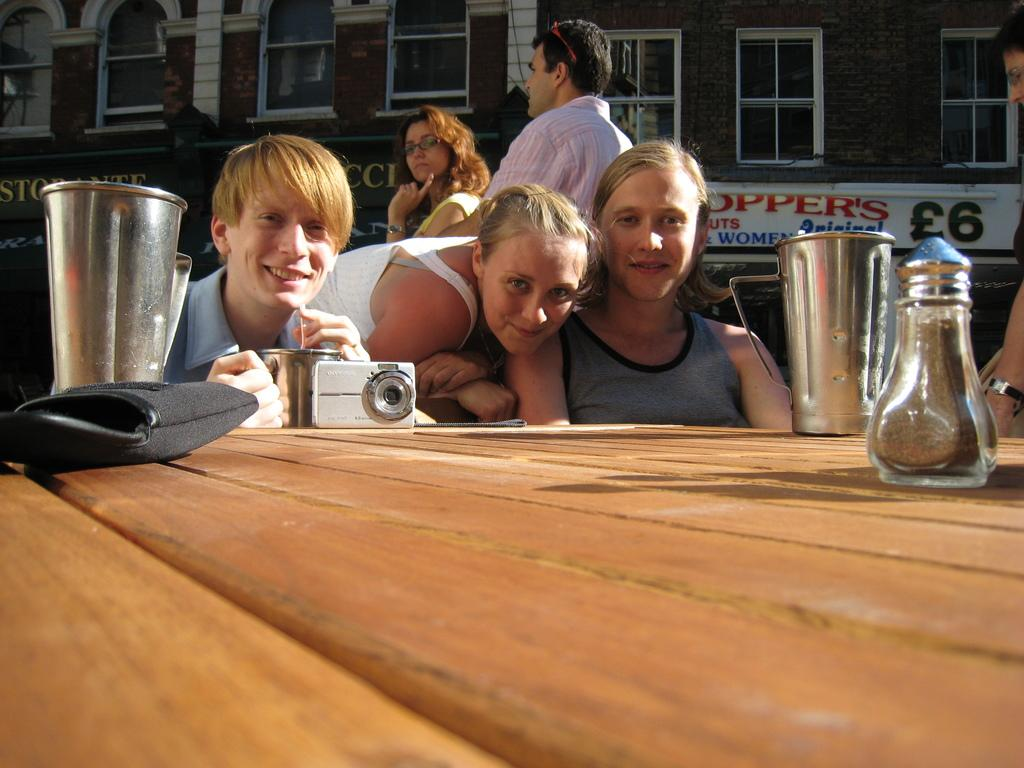Who is present in the image? There are people in the image. What are the people doing in the image? The people are seeing and smiling. What type of furniture is in the image? There is a wooden table in the image. What is on the wooden table? Items are placed on the wooden table. What can be seen in the background of the image? There is a banner and a building in the background of the image, along with windows. How many friends are tied in a knot in the image? There are no friends or knots present in the image. 